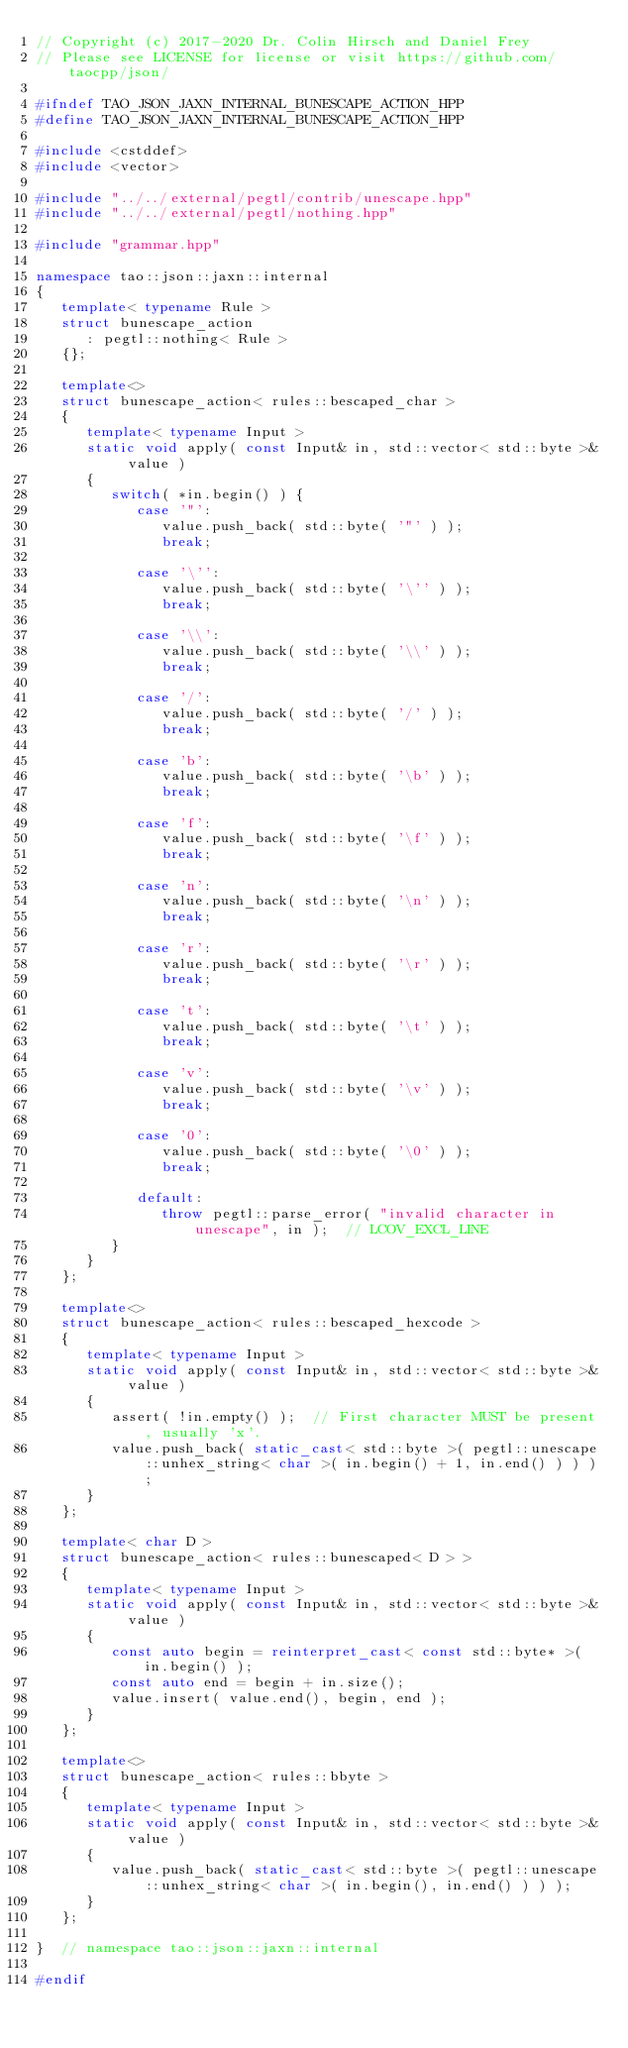Convert code to text. <code><loc_0><loc_0><loc_500><loc_500><_C++_>// Copyright (c) 2017-2020 Dr. Colin Hirsch and Daniel Frey
// Please see LICENSE for license or visit https://github.com/taocpp/json/

#ifndef TAO_JSON_JAXN_INTERNAL_BUNESCAPE_ACTION_HPP
#define TAO_JSON_JAXN_INTERNAL_BUNESCAPE_ACTION_HPP

#include <cstddef>
#include <vector>

#include "../../external/pegtl/contrib/unescape.hpp"
#include "../../external/pegtl/nothing.hpp"

#include "grammar.hpp"

namespace tao::json::jaxn::internal
{
   template< typename Rule >
   struct bunescape_action
      : pegtl::nothing< Rule >
   {};

   template<>
   struct bunescape_action< rules::bescaped_char >
   {
      template< typename Input >
      static void apply( const Input& in, std::vector< std::byte >& value )
      {
         switch( *in.begin() ) {
            case '"':
               value.push_back( std::byte( '"' ) );
               break;

            case '\'':
               value.push_back( std::byte( '\'' ) );
               break;

            case '\\':
               value.push_back( std::byte( '\\' ) );
               break;

            case '/':
               value.push_back( std::byte( '/' ) );
               break;

            case 'b':
               value.push_back( std::byte( '\b' ) );
               break;

            case 'f':
               value.push_back( std::byte( '\f' ) );
               break;

            case 'n':
               value.push_back( std::byte( '\n' ) );
               break;

            case 'r':
               value.push_back( std::byte( '\r' ) );
               break;

            case 't':
               value.push_back( std::byte( '\t' ) );
               break;

            case 'v':
               value.push_back( std::byte( '\v' ) );
               break;

            case '0':
               value.push_back( std::byte( '\0' ) );
               break;

            default:
               throw pegtl::parse_error( "invalid character in unescape", in );  // LCOV_EXCL_LINE
         }
      }
   };

   template<>
   struct bunescape_action< rules::bescaped_hexcode >
   {
      template< typename Input >
      static void apply( const Input& in, std::vector< std::byte >& value )
      {
         assert( !in.empty() );  // First character MUST be present, usually 'x'.
         value.push_back( static_cast< std::byte >( pegtl::unescape::unhex_string< char >( in.begin() + 1, in.end() ) ) );
      }
   };

   template< char D >
   struct bunescape_action< rules::bunescaped< D > >
   {
      template< typename Input >
      static void apply( const Input& in, std::vector< std::byte >& value )
      {
         const auto begin = reinterpret_cast< const std::byte* >( in.begin() );
         const auto end = begin + in.size();
         value.insert( value.end(), begin, end );
      }
   };

   template<>
   struct bunescape_action< rules::bbyte >
   {
      template< typename Input >
      static void apply( const Input& in, std::vector< std::byte >& value )
      {
         value.push_back( static_cast< std::byte >( pegtl::unescape::unhex_string< char >( in.begin(), in.end() ) ) );
      }
   };

}  // namespace tao::json::jaxn::internal

#endif
</code> 